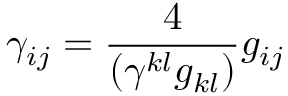Convert formula to latex. <formula><loc_0><loc_0><loc_500><loc_500>\gamma _ { i j } = \frac { 4 } { ( \gamma ^ { k l } g _ { k l } ) } g _ { i j }</formula> 